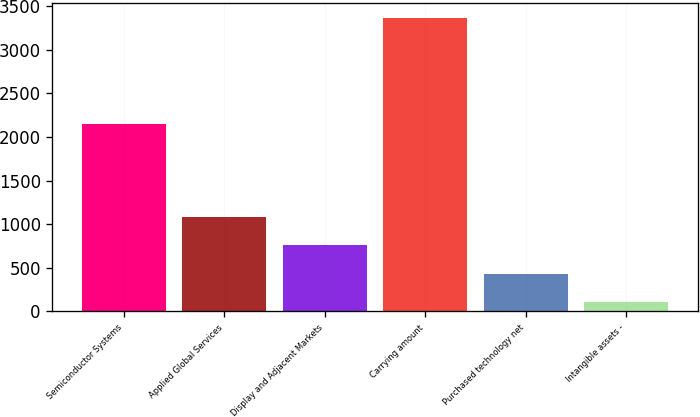Convert chart. <chart><loc_0><loc_0><loc_500><loc_500><bar_chart><fcel>Semiconductor Systems<fcel>Applied Global Services<fcel>Display and Adjacent Markets<fcel>Carrying amount<fcel>Purchased technology net<fcel>Intangible assets -<nl><fcel>2151<fcel>1083.2<fcel>756.8<fcel>3368<fcel>430.4<fcel>104<nl></chart> 